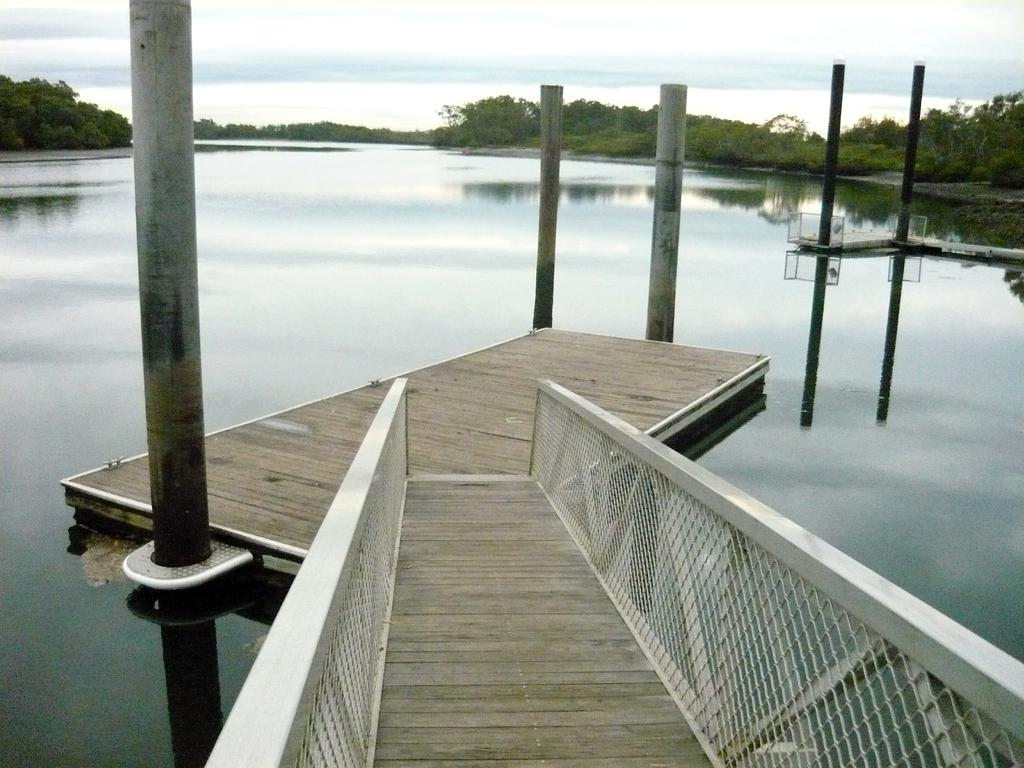What is located in the center of the image? There is a platform in the center of the image. What can be seen in the background of the image? There are poles, water, trees, and the sky visible in the background of the image. What type of poisonous seed can be seen growing on the platform in the image? There is no mention of seeds or poison in the image, and the platform does not appear to have any plants growing on it. 